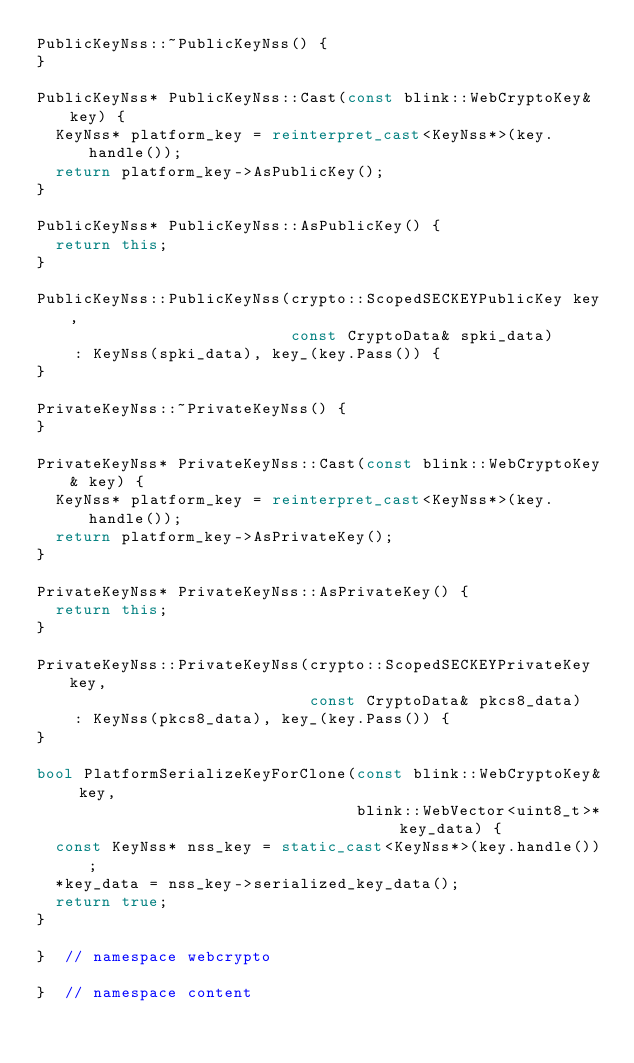<code> <loc_0><loc_0><loc_500><loc_500><_C++_>PublicKeyNss::~PublicKeyNss() {
}

PublicKeyNss* PublicKeyNss::Cast(const blink::WebCryptoKey& key) {
  KeyNss* platform_key = reinterpret_cast<KeyNss*>(key.handle());
  return platform_key->AsPublicKey();
}

PublicKeyNss* PublicKeyNss::AsPublicKey() {
  return this;
}

PublicKeyNss::PublicKeyNss(crypto::ScopedSECKEYPublicKey key,
                           const CryptoData& spki_data)
    : KeyNss(spki_data), key_(key.Pass()) {
}

PrivateKeyNss::~PrivateKeyNss() {
}

PrivateKeyNss* PrivateKeyNss::Cast(const blink::WebCryptoKey& key) {
  KeyNss* platform_key = reinterpret_cast<KeyNss*>(key.handle());
  return platform_key->AsPrivateKey();
}

PrivateKeyNss* PrivateKeyNss::AsPrivateKey() {
  return this;
}

PrivateKeyNss::PrivateKeyNss(crypto::ScopedSECKEYPrivateKey key,
                             const CryptoData& pkcs8_data)
    : KeyNss(pkcs8_data), key_(key.Pass()) {
}

bool PlatformSerializeKeyForClone(const blink::WebCryptoKey& key,
                                  blink::WebVector<uint8_t>* key_data) {
  const KeyNss* nss_key = static_cast<KeyNss*>(key.handle());
  *key_data = nss_key->serialized_key_data();
  return true;
}

}  // namespace webcrypto

}  // namespace content
</code> 